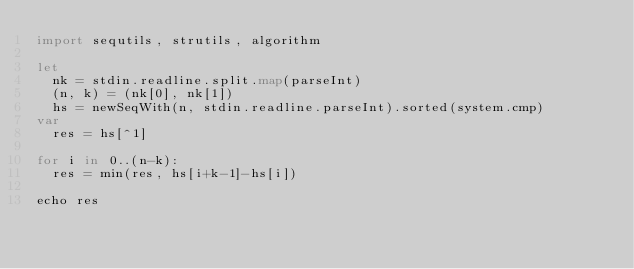Convert code to text. <code><loc_0><loc_0><loc_500><loc_500><_Nim_>import sequtils, strutils, algorithm

let
  nk = stdin.readline.split.map(parseInt)
  (n, k) = (nk[0], nk[1])
  hs = newSeqWith(n, stdin.readline.parseInt).sorted(system.cmp)
var
  res = hs[^1]

for i in 0..(n-k):
  res = min(res, hs[i+k-1]-hs[i])

echo res
</code> 